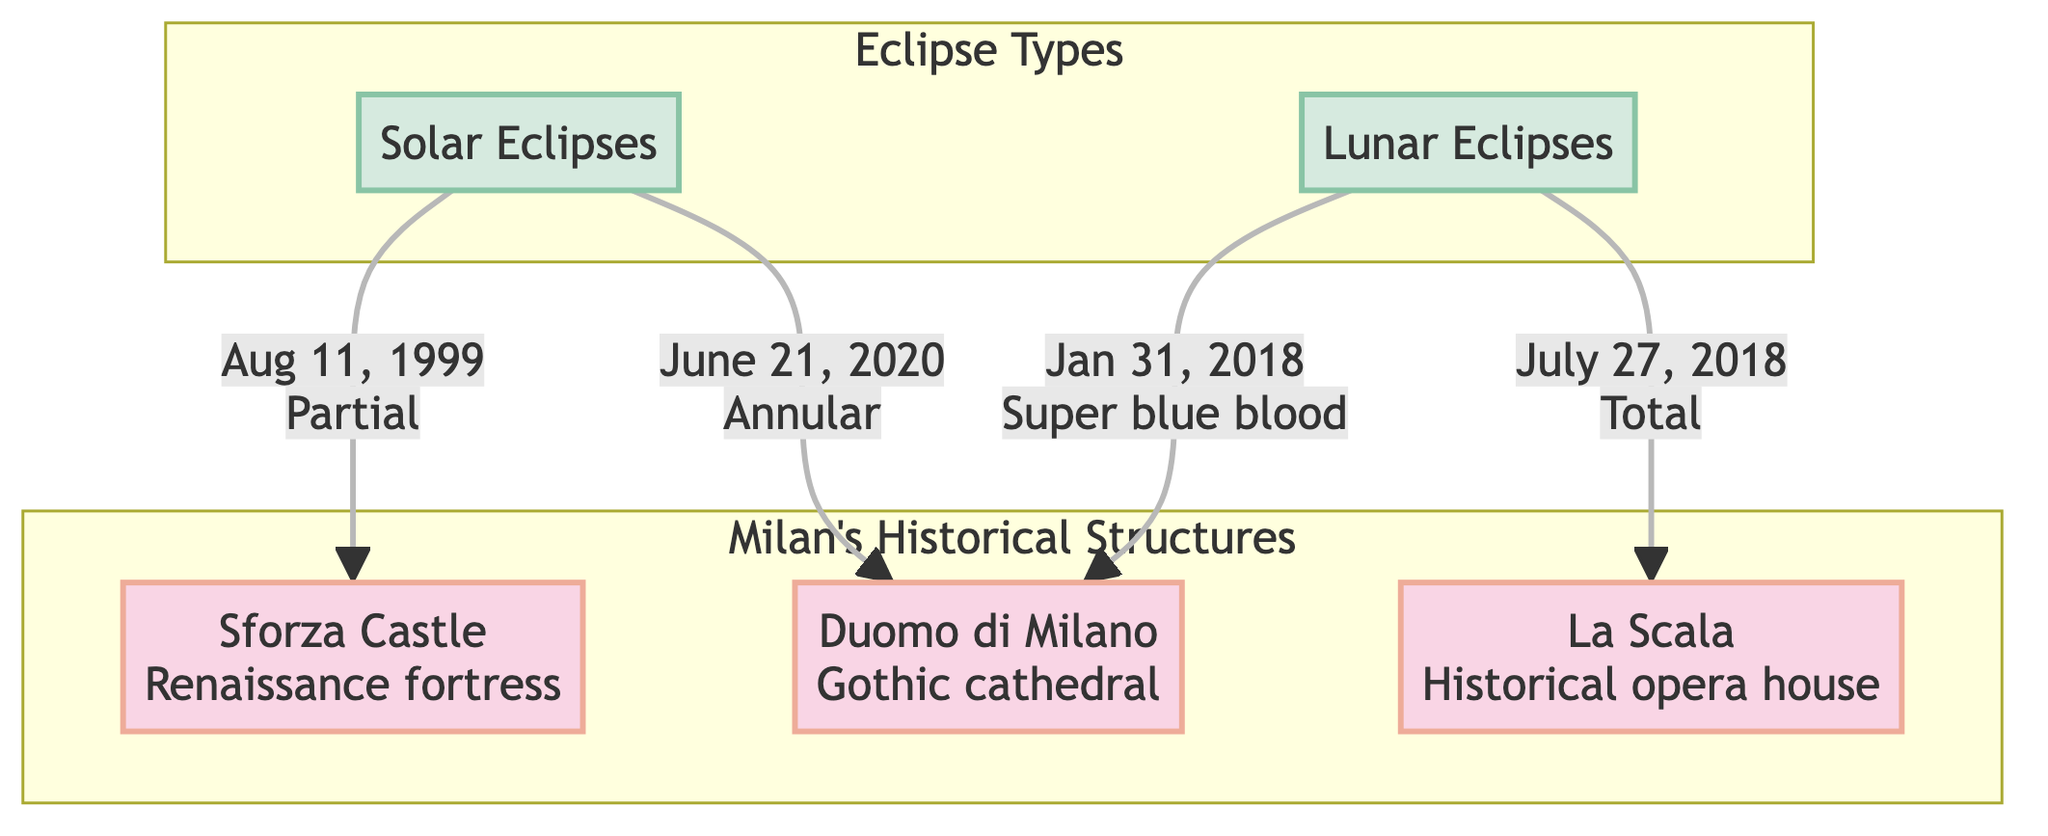What is the first eclipse type listed in the diagram? The diagram has two eclipse types: 'Solar Eclipses' and 'Lunar Eclipses'. The first one mentioned is 'Solar Eclipses'.
Answer: Solar Eclipses How many famous Milanese structures are represented in the diagram? The diagram includes three structures: Duomo di Milano, Sforza Castle, and La Scala. Therefore, the total is three structures.
Answer: 3 Which structure witnessed a total lunar eclipse? The diagram shows that La Scala experienced a total lunar eclipse on July 27, 2018.
Answer: La Scala What type of solar eclipse did Duomo di Milano witness, and when? According to the diagram, Duomo di Milano witnessed an annular solar eclipse on June 21, 2020.
Answer: Annular on June 21, 2020 How many lunar eclipses are shown in the diagram? The diagram specifies two lunar eclipses: one on July 27, 2018, and another on January 31, 2018, indicating a total of two lunar eclipses.
Answer: 2 What specific event is referred to as "Super blue blood" in the diagram? "Super blue blood" refers to a lunar eclipse that occurred on January 31, 2018, at Duomo di Milano, showcasing its uniqueness.
Answer: Super blue blood on January 31, 2018 Which structure experienced a partial solar eclipse, and when did this occur? Sforza Castle is connected to a partial solar eclipse that occurred on August 11, 1999, as indicated in the diagram.
Answer: Sforza Castle on August 11, 1999 What color theme separates the structure nodes from the eclipse nodes? The diagram uses different colors for the categories: the structure nodes are filled with a pinkish hue while the eclipse nodes are filled with a light blue color.
Answer: Pinkish and light blue colors 